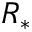<formula> <loc_0><loc_0><loc_500><loc_500>R _ { * }</formula> 